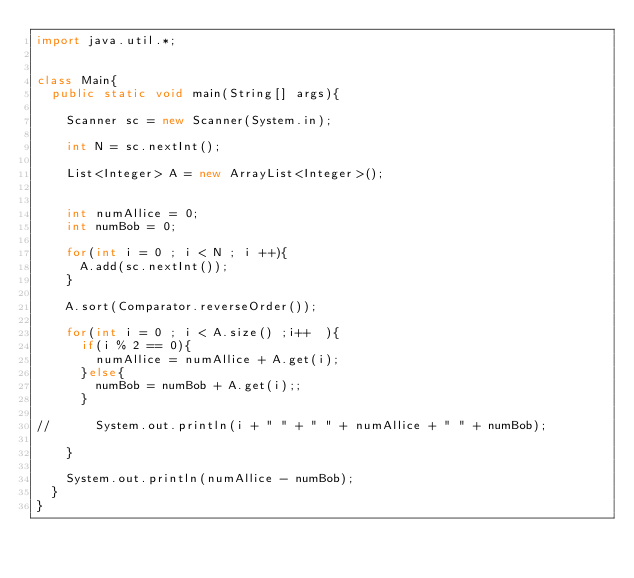Convert code to text. <code><loc_0><loc_0><loc_500><loc_500><_Java_>import java.util.*;


class Main{
	public static void main(String[] args){
		
		Scanner sc = new Scanner(System.in);
		
		int N = sc.nextInt();
		
		List<Integer> A = new ArrayList<Integer>();
		
		
		int numAllice = 0;
		int numBob = 0;
		
		for(int i = 0 ; i < N ; i ++){
			A.add(sc.nextInt());
		}
		
		A.sort(Comparator.reverseOrder());  
		
		for(int i = 0 ; i < A.size() ;i++  ){
			if(i % 2 == 0){
				numAllice = numAllice + A.get(i);
			}else{
				numBob = numBob + A.get(i);;
			}
			
//			System.out.println(i + " " + " " + numAllice + " " + numBob);
			
		}
		
		System.out.println(numAllice - numBob);
	}
}
</code> 